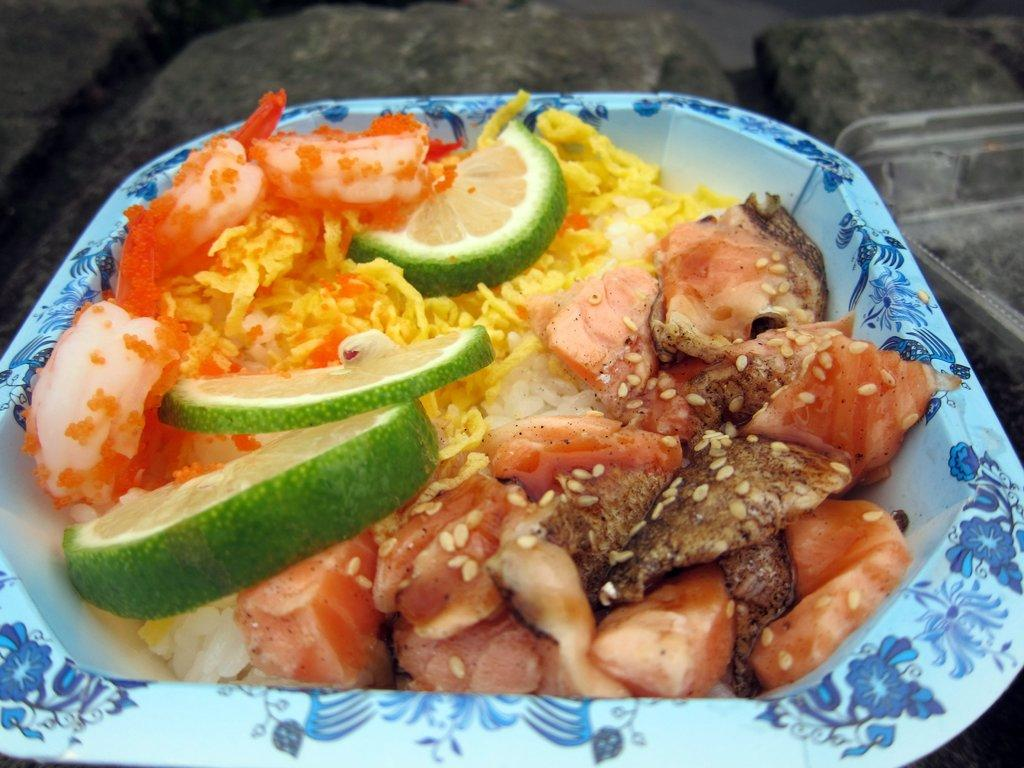What type of cooked food can be seen in the image? There is a cooked food item in the image. How is the food item decorated or garnished? The food item is topped with lemon slices. In what type of container is the food item served? The food item is served in a bowl. Where is the father sitting in the image? There is no father present in the image; it only features a cooked food item served in a bowl with lemon slices on top. How many spiders are crawling on the lemon slices in the image? There are no spiders present in the image; it only features a cooked food item served in a bowl with lemon slices on top. 